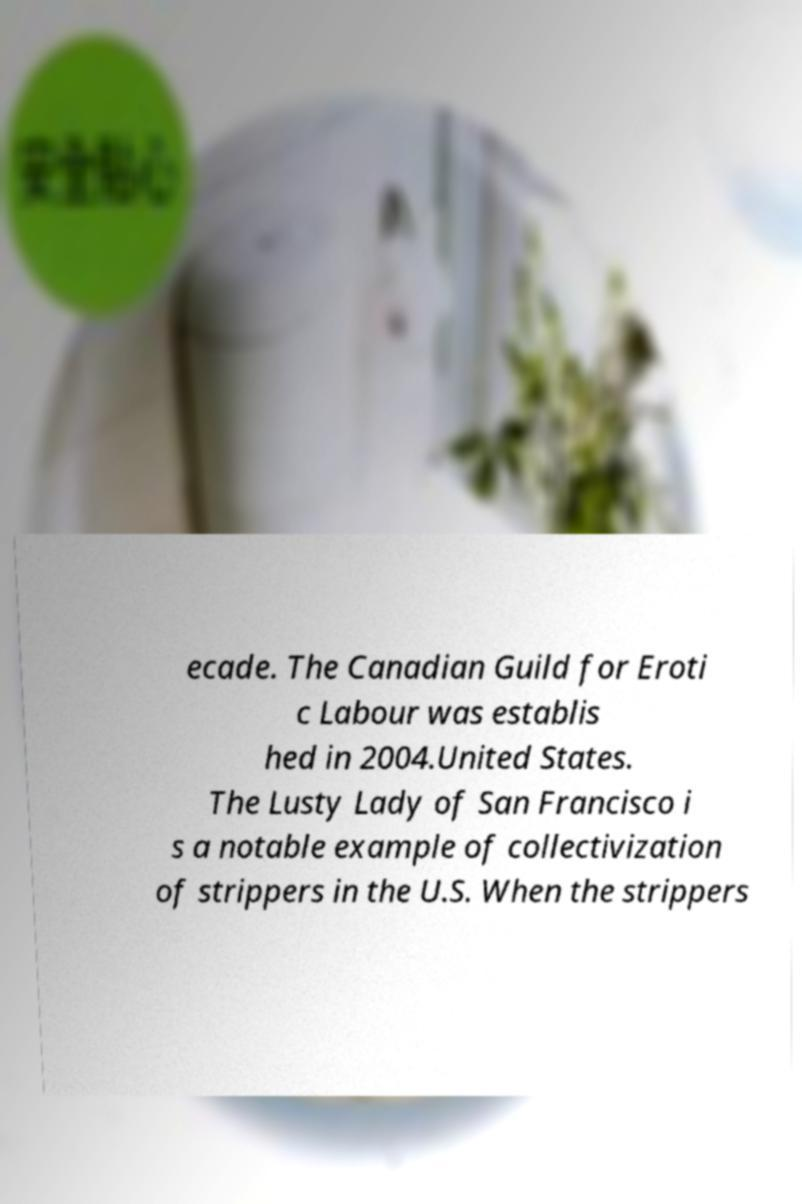Please read and relay the text visible in this image. What does it say? ecade. The Canadian Guild for Eroti c Labour was establis hed in 2004.United States. The Lusty Lady of San Francisco i s a notable example of collectivization of strippers in the U.S. When the strippers 